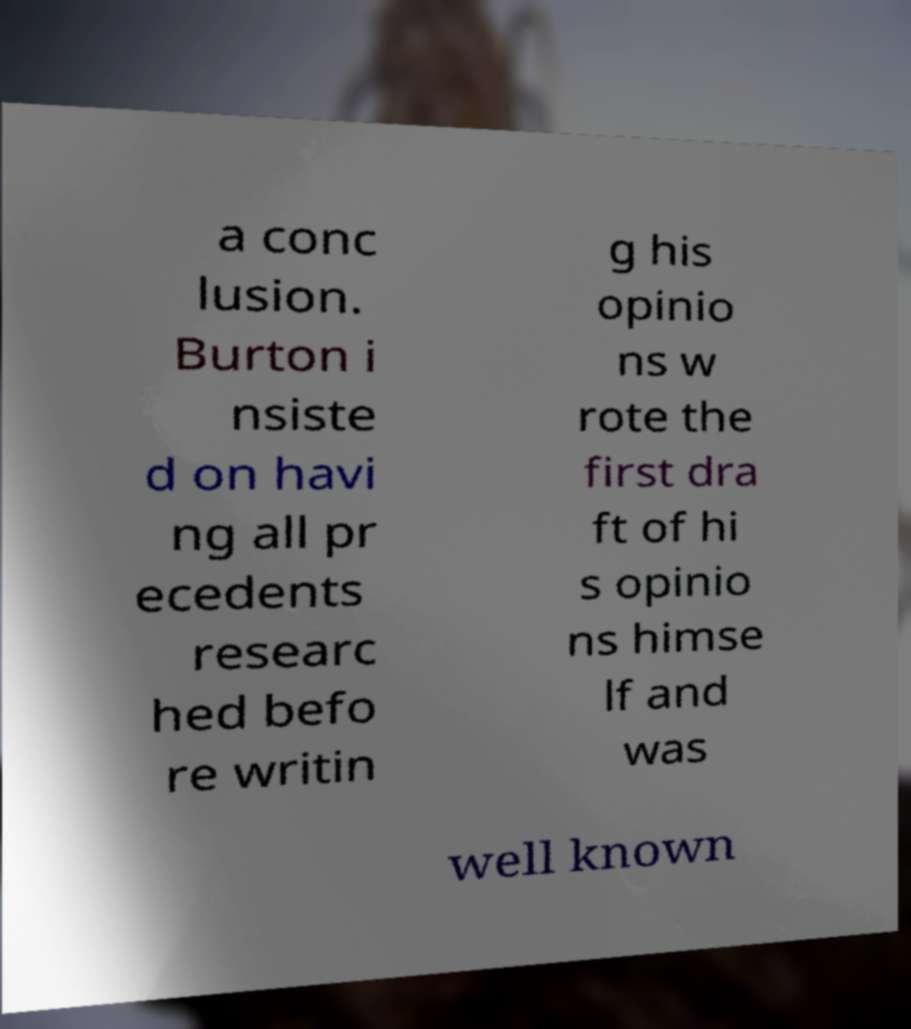Could you extract and type out the text from this image? a conc lusion. Burton i nsiste d on havi ng all pr ecedents researc hed befo re writin g his opinio ns w rote the first dra ft of hi s opinio ns himse lf and was well known 